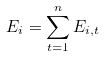<formula> <loc_0><loc_0><loc_500><loc_500>E _ { i } = \sum _ { t = 1 } ^ { n } E _ { i , t }</formula> 